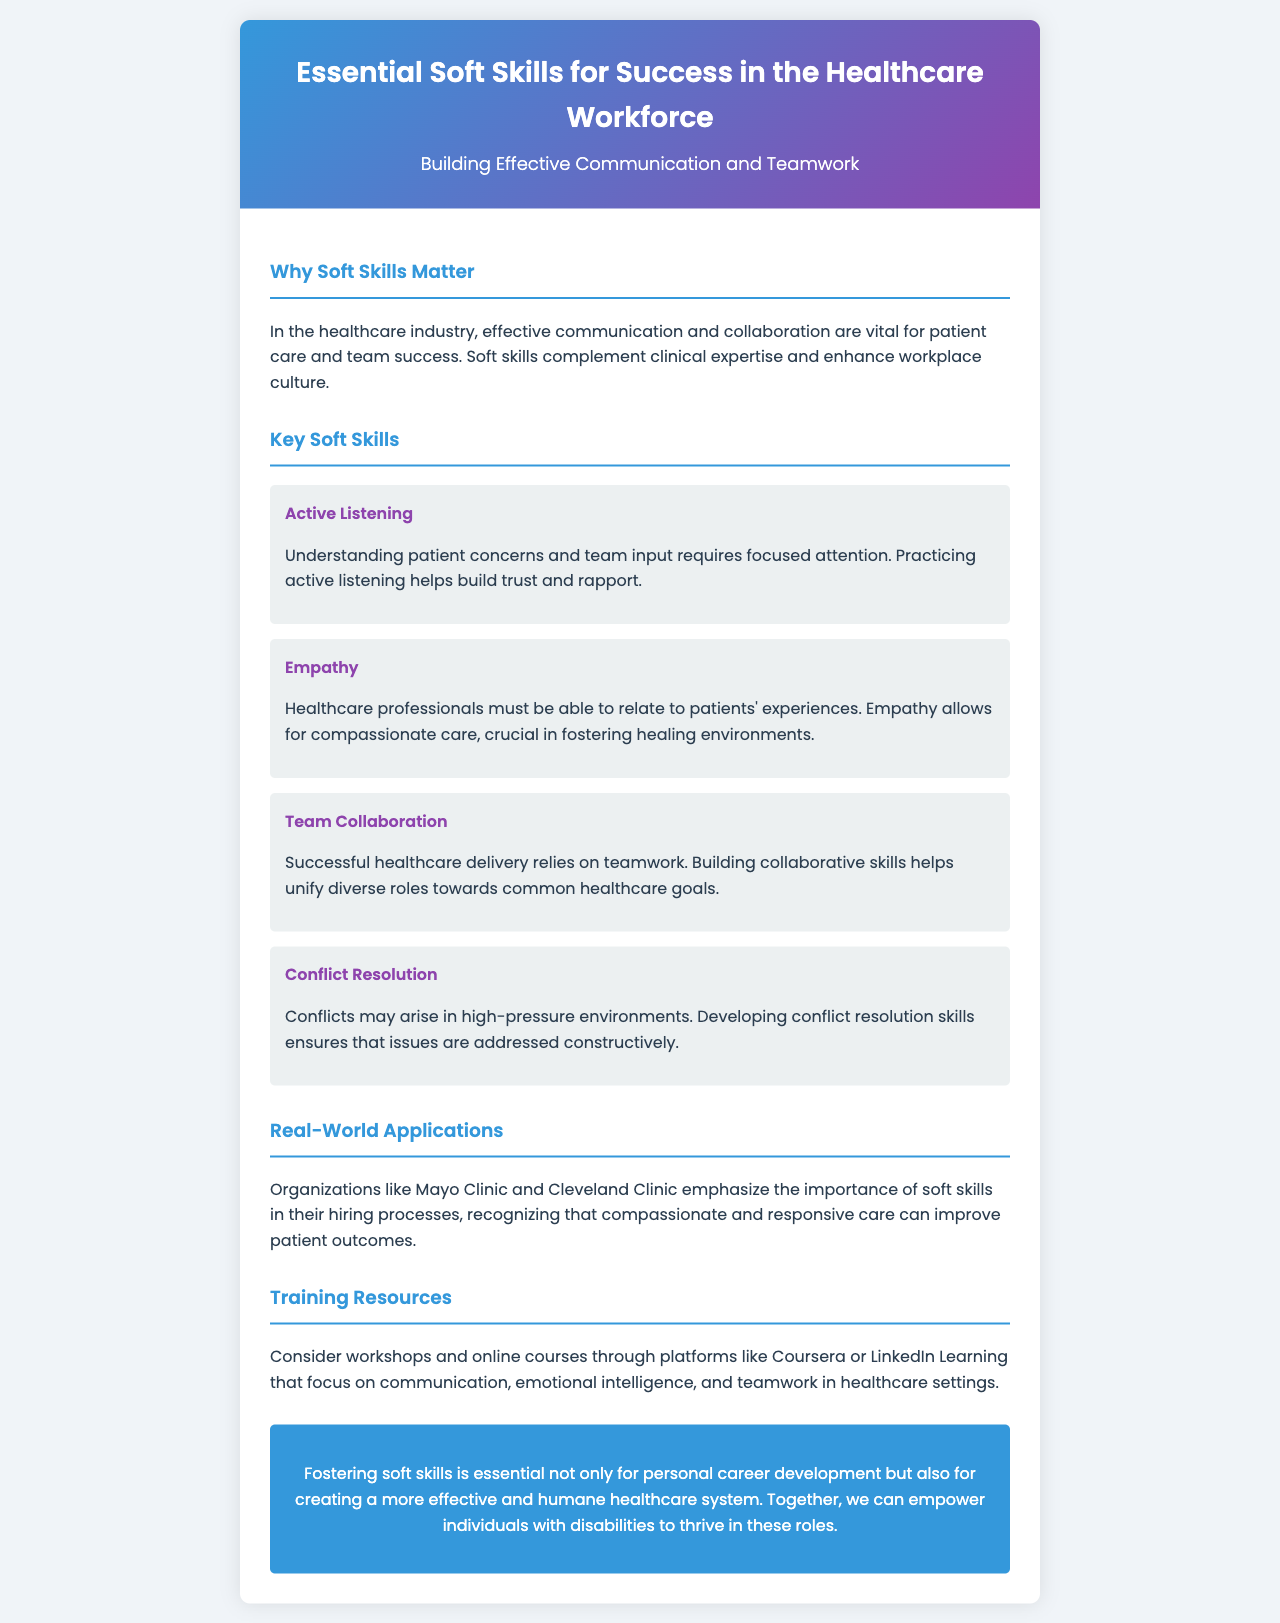What is the title of the brochure? The title is stated in the header section of the document.
Answer: Essential Soft Skills for Success in the Healthcare Workforce What are the key soft skills mentioned? The document lists specific skills in the "Key Soft Skills" section.
Answer: Active Listening, Empathy, Team Collaboration, Conflict Resolution What is emphasized as vital for patient care in the document? The text highlights the role of effective communication and collaboration in healthcare.
Answer: Effective communication and collaboration Which organizations are mentioned as valuing soft skills in hiring? The "Real-World Applications" section references notable healthcare organizations.
Answer: Mayo Clinic and Cleveland Clinic What type of resources are recommended for training? The document suggests specific formats for improving soft skills in healthcare.
Answer: Workshops and online courses How does the brochure describe empathy? The document provides a definition emphasizing its importance in patient care.
Answer: Allows for compassionate care What is the main purpose of fostering soft skills according to the conclusion? The conclusion summarizes the rationale behind developing soft skills.
Answer: Personal career development and effective healthcare system What is the background color of the brochure? The overall document design specifies its visual characteristics in the body style.
Answer: White 